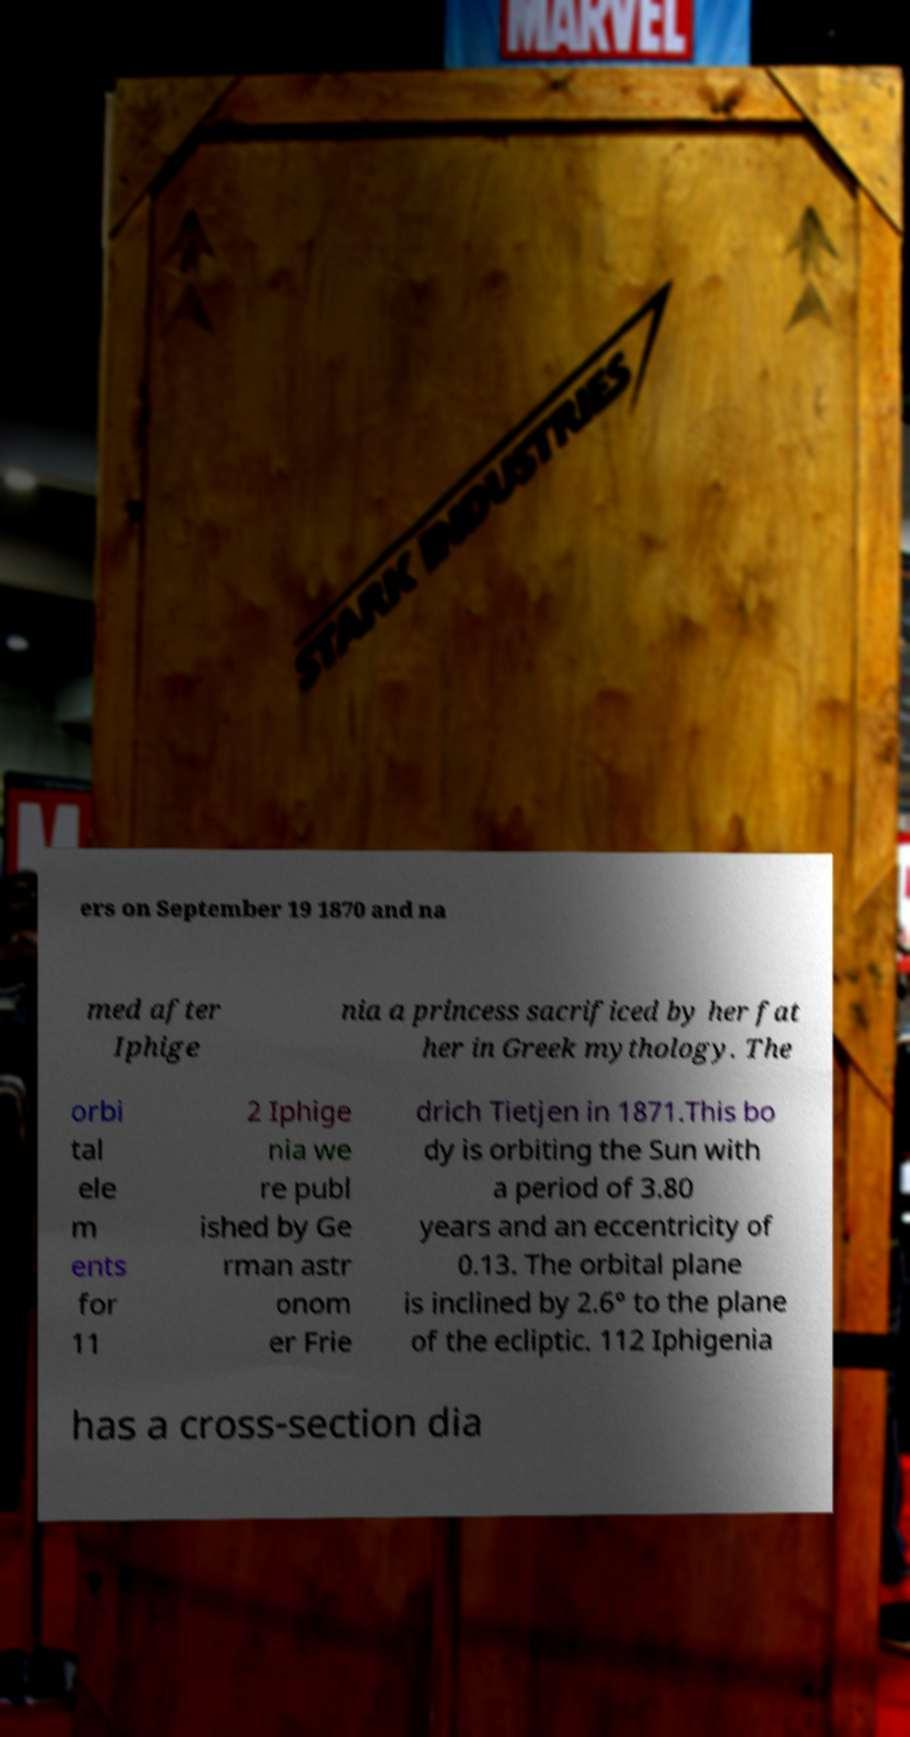Can you accurately transcribe the text from the provided image for me? ers on September 19 1870 and na med after Iphige nia a princess sacrificed by her fat her in Greek mythology. The orbi tal ele m ents for 11 2 Iphige nia we re publ ished by Ge rman astr onom er Frie drich Tietjen in 1871.This bo dy is orbiting the Sun with a period of 3.80 years and an eccentricity of 0.13. The orbital plane is inclined by 2.6° to the plane of the ecliptic. 112 Iphigenia has a cross-section dia 